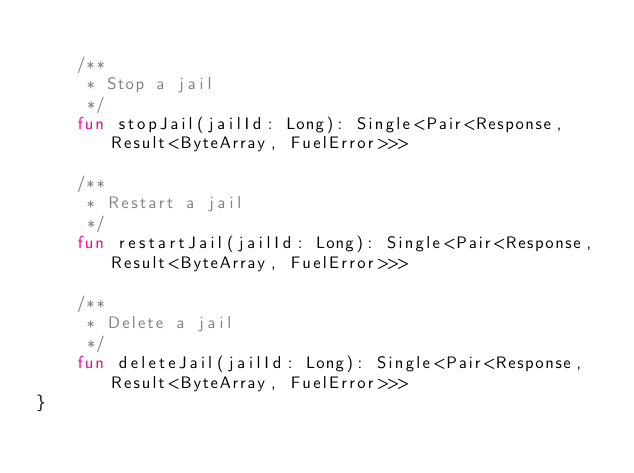<code> <loc_0><loc_0><loc_500><loc_500><_Kotlin_>
    /**
     * Stop a jail
     */
    fun stopJail(jailId: Long): Single<Pair<Response, Result<ByteArray, FuelError>>>

    /**
     * Restart a jail
     */
    fun restartJail(jailId: Long): Single<Pair<Response, Result<ByteArray, FuelError>>>

    /**
     * Delete a jail
     */
    fun deleteJail(jailId: Long): Single<Pair<Response, Result<ByteArray, FuelError>>>
}</code> 